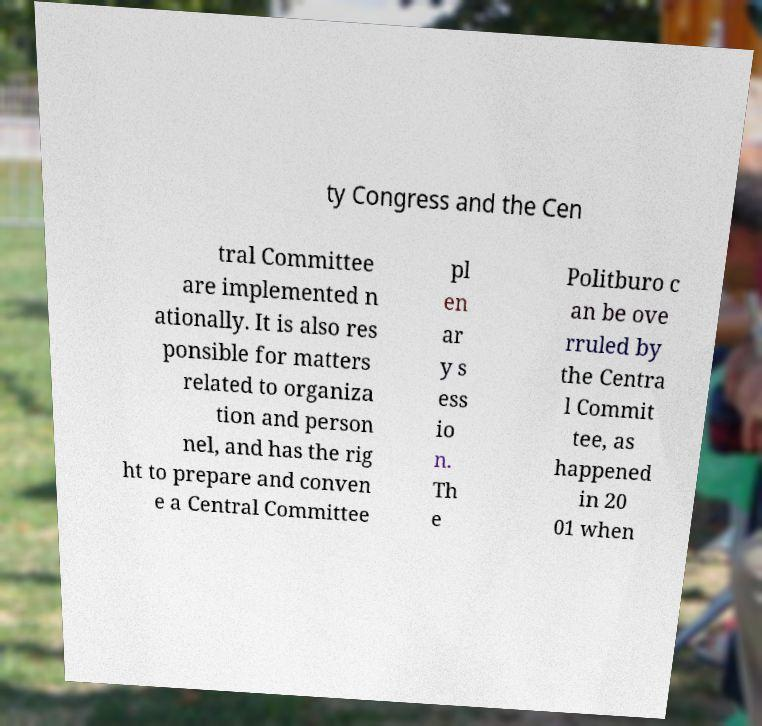Could you extract and type out the text from this image? ty Congress and the Cen tral Committee are implemented n ationally. It is also res ponsible for matters related to organiza tion and person nel, and has the rig ht to prepare and conven e a Central Committee pl en ar y s ess io n. Th e Politburo c an be ove rruled by the Centra l Commit tee, as happened in 20 01 when 